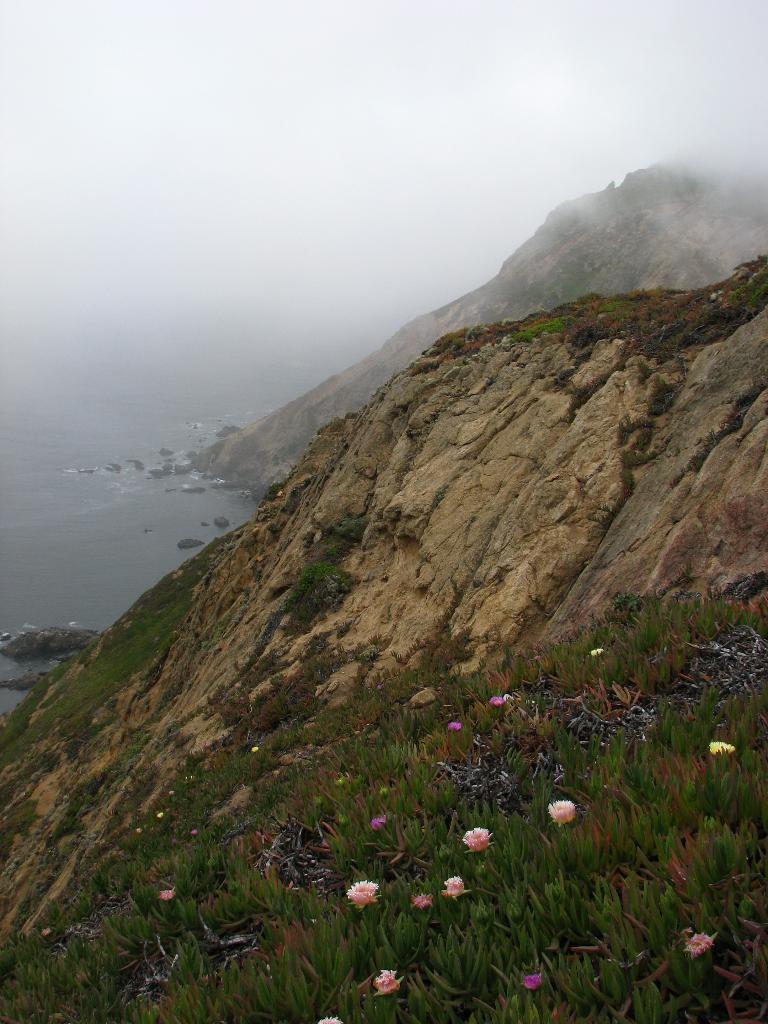In one or two sentences, can you explain what this image depicts? On the left side of the image we can see the water. In the background of the image we can see the hills, grass. At the bottom of the image we can see the plants and flowers. At the top of the image we can see the sky. 